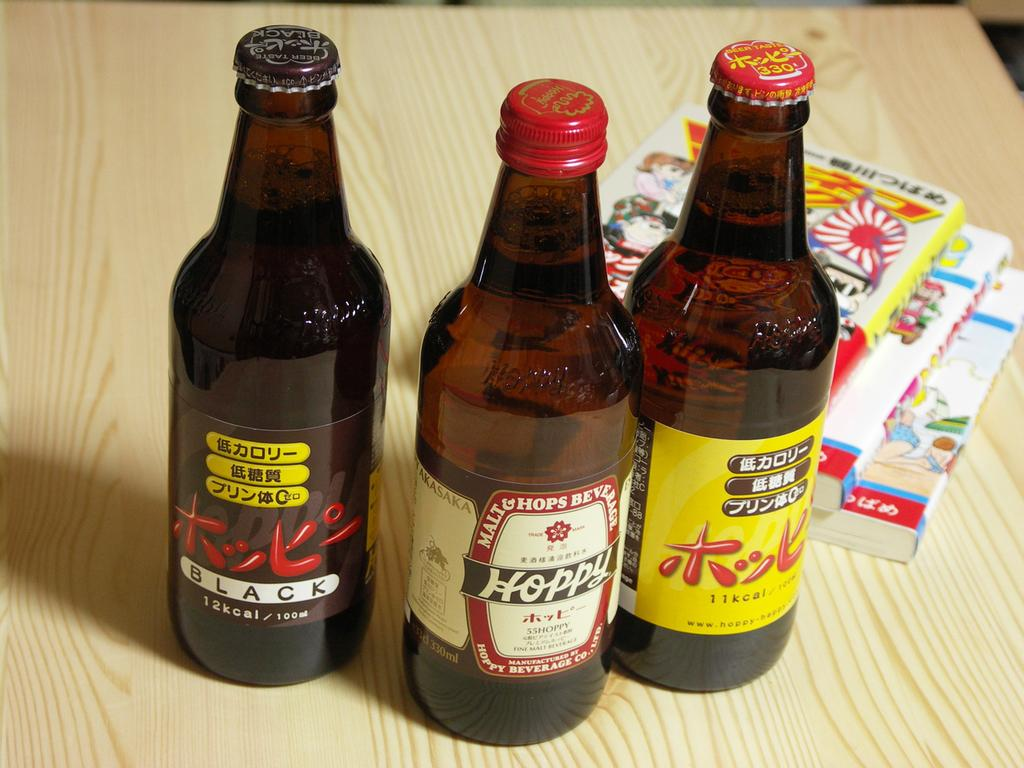<image>
Relay a brief, clear account of the picture shown. Three bottles are on a table with the far left one being labeled black. 